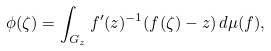<formula> <loc_0><loc_0><loc_500><loc_500>\phi ( \zeta ) = \int _ { G _ { z } } f ^ { \prime } ( z ) ^ { - 1 } ( f ( \zeta ) - z ) \, d \mu ( f ) ,</formula> 